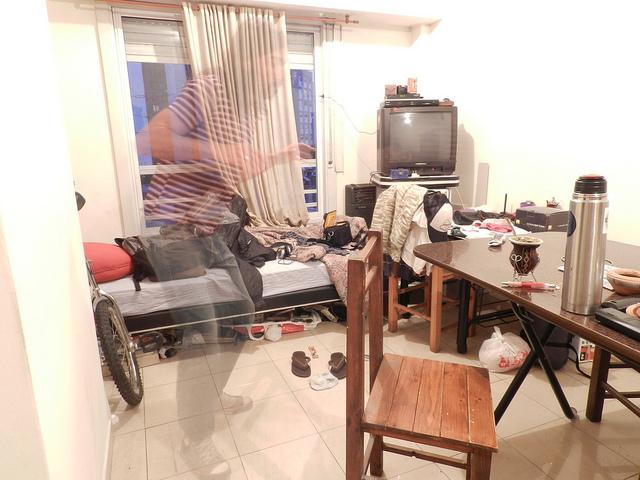The way the person appears makes them look like what type of being?

Choices:
A) ghost
B) werewolf
C) vampire
D) wendigo ghost 